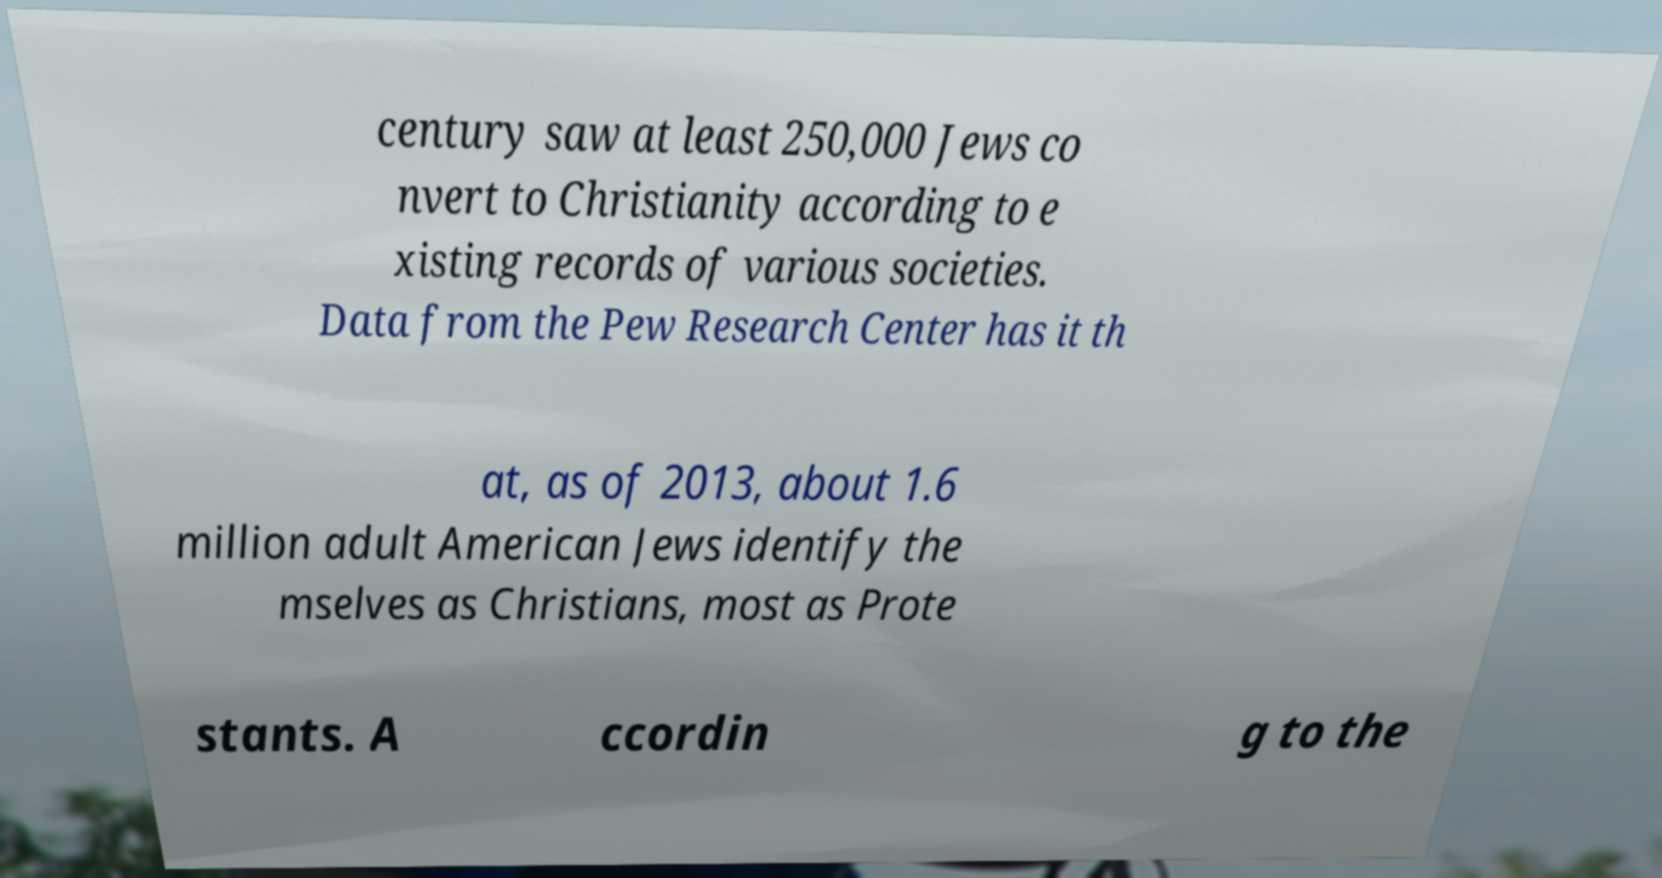Can you accurately transcribe the text from the provided image for me? century saw at least 250,000 Jews co nvert to Christianity according to e xisting records of various societies. Data from the Pew Research Center has it th at, as of 2013, about 1.6 million adult American Jews identify the mselves as Christians, most as Prote stants. A ccordin g to the 